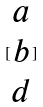Convert formula to latex. <formula><loc_0><loc_0><loc_500><loc_500>[ \begin{matrix} a \\ b \\ d \end{matrix} ]</formula> 